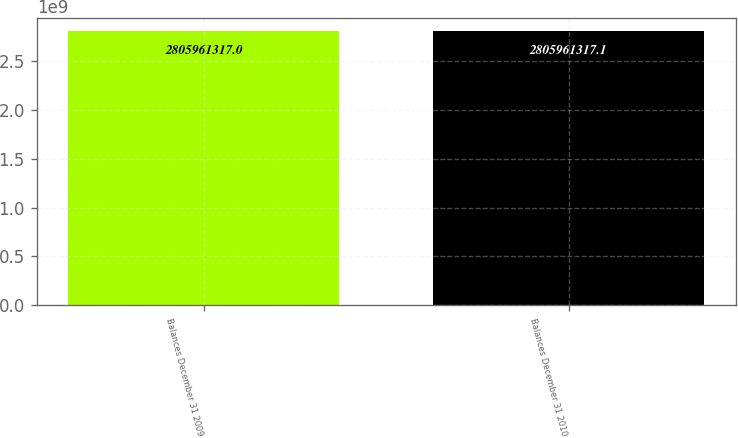<chart> <loc_0><loc_0><loc_500><loc_500><bar_chart><fcel>Balances December 31 2009<fcel>Balances December 31 2010<nl><fcel>2.80596e+09<fcel>2.80596e+09<nl></chart> 